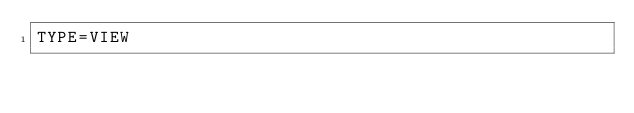<code> <loc_0><loc_0><loc_500><loc_500><_VisualBasic_>TYPE=VIEW</code> 